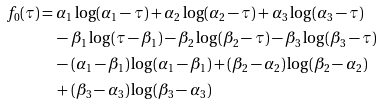<formula> <loc_0><loc_0><loc_500><loc_500>f _ { 0 } ( \tau ) & = \alpha _ { 1 } \log ( \alpha _ { 1 } - \tau ) + \alpha _ { 2 } \log ( \alpha _ { 2 } - \tau ) + \alpha _ { 3 } \log ( \alpha _ { 3 } - \tau ) \\ & \quad - \beta _ { 1 } \log ( \tau - \beta _ { 1 } ) - \beta _ { 2 } \log ( \beta _ { 2 } - \tau ) - \beta _ { 3 } \log ( \beta _ { 3 } - \tau ) \\ & \quad - ( \alpha _ { 1 } - \beta _ { 1 } ) \log ( \alpha _ { 1 } - \beta _ { 1 } ) + ( \beta _ { 2 } - \alpha _ { 2 } ) \log ( \beta _ { 2 } - \alpha _ { 2 } ) \\ & \quad + ( \beta _ { 3 } - \alpha _ { 3 } ) \log ( \beta _ { 3 } - \alpha _ { 3 } )</formula> 